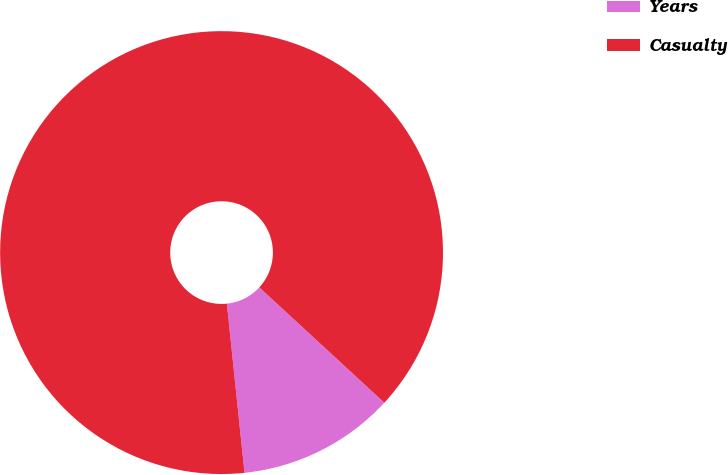Convert chart. <chart><loc_0><loc_0><loc_500><loc_500><pie_chart><fcel>Years<fcel>Casualty<nl><fcel>11.49%<fcel>88.51%<nl></chart> 